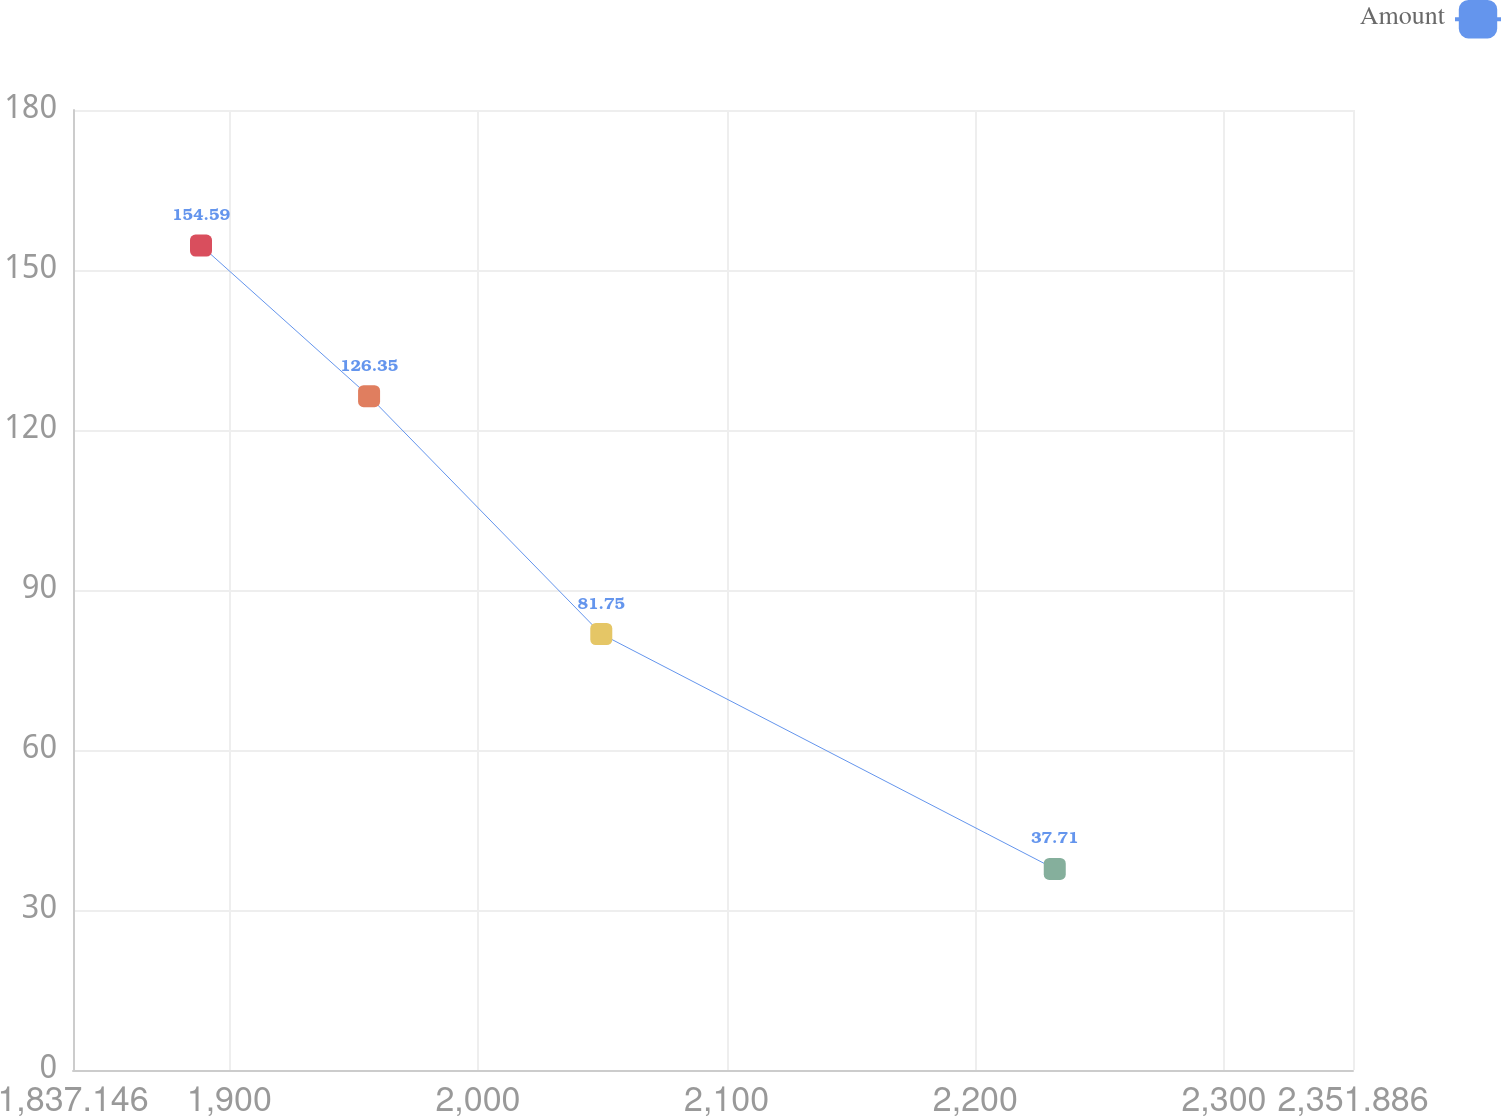Convert chart. <chart><loc_0><loc_0><loc_500><loc_500><line_chart><ecel><fcel>Amount<nl><fcel>1888.62<fcel>154.59<nl><fcel>1956.21<fcel>126.35<nl><fcel>2049.59<fcel>81.75<nl><fcel>2231.95<fcel>37.71<nl><fcel>2403.36<fcel>13.25<nl></chart> 